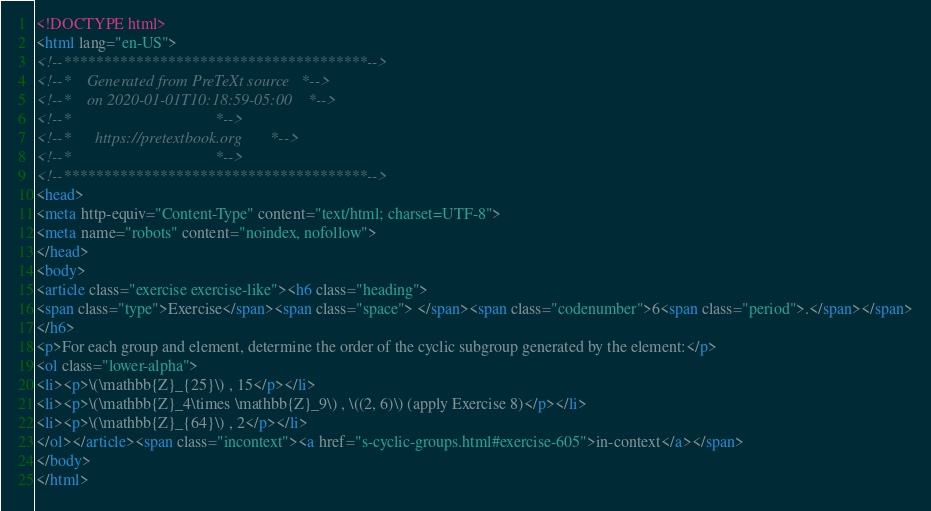<code> <loc_0><loc_0><loc_500><loc_500><_HTML_><!DOCTYPE html>
<html lang="en-US">
<!--**************************************-->
<!--*    Generated from PreTeXt source   *-->
<!--*    on 2020-01-01T10:18:59-05:00    *-->
<!--*                                    *-->
<!--*      https://pretextbook.org       *-->
<!--*                                    *-->
<!--**************************************-->
<head>
<meta http-equiv="Content-Type" content="text/html; charset=UTF-8">
<meta name="robots" content="noindex, nofollow">
</head>
<body>
<article class="exercise exercise-like"><h6 class="heading">
<span class="type">Exercise</span><span class="space"> </span><span class="codenumber">6<span class="period">.</span></span>
</h6>
<p>For each group and element, determine the order of the cyclic subgroup generated by the element:</p>
<ol class="lower-alpha">
<li><p>\(\mathbb{Z}_{25}\) , 15</p></li>
<li><p>\(\mathbb{Z}_4\times \mathbb{Z}_9\) , \((2, 6)\) (apply Exercise 8)</p></li>
<li><p>\(\mathbb{Z}_{64}\) , 2</p></li>
</ol></article><span class="incontext"><a href="s-cyclic-groups.html#exercise-605">in-context</a></span>
</body>
</html>
</code> 